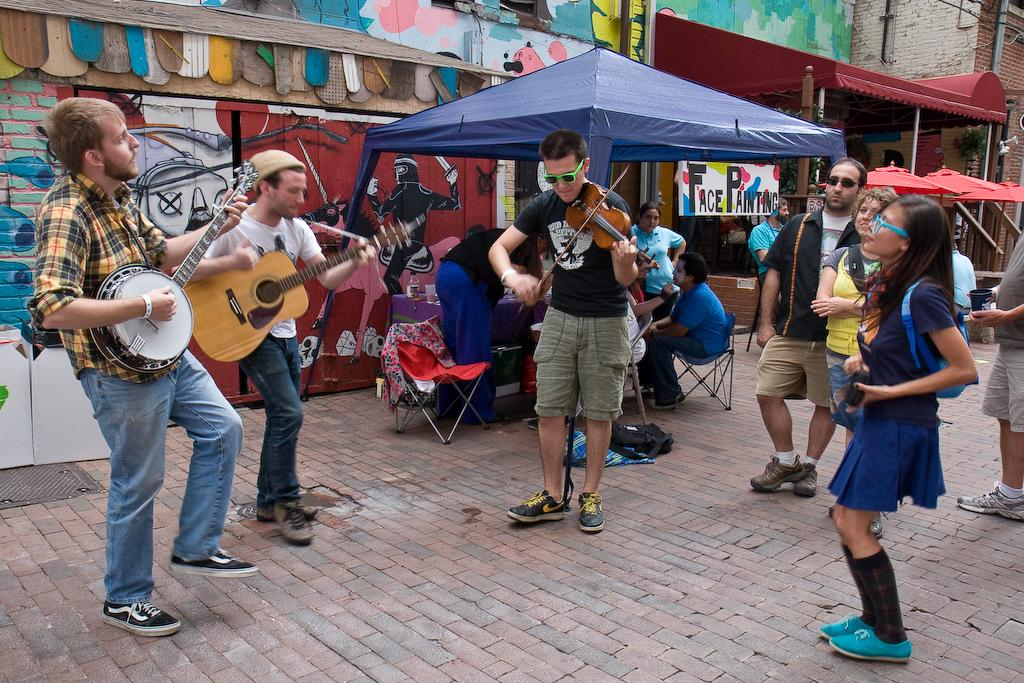What is happening in the image? There is a group of people in the image, and some of them are playing musical instruments. What are the people doing while playing the instruments? Some people are sitting on chairs while playing the musical instruments. What type of dress is the boot wearing in the image? There is no dress or boot present in the image; it features a group of people, some of whom are playing musical instruments and sitting on chairs. 